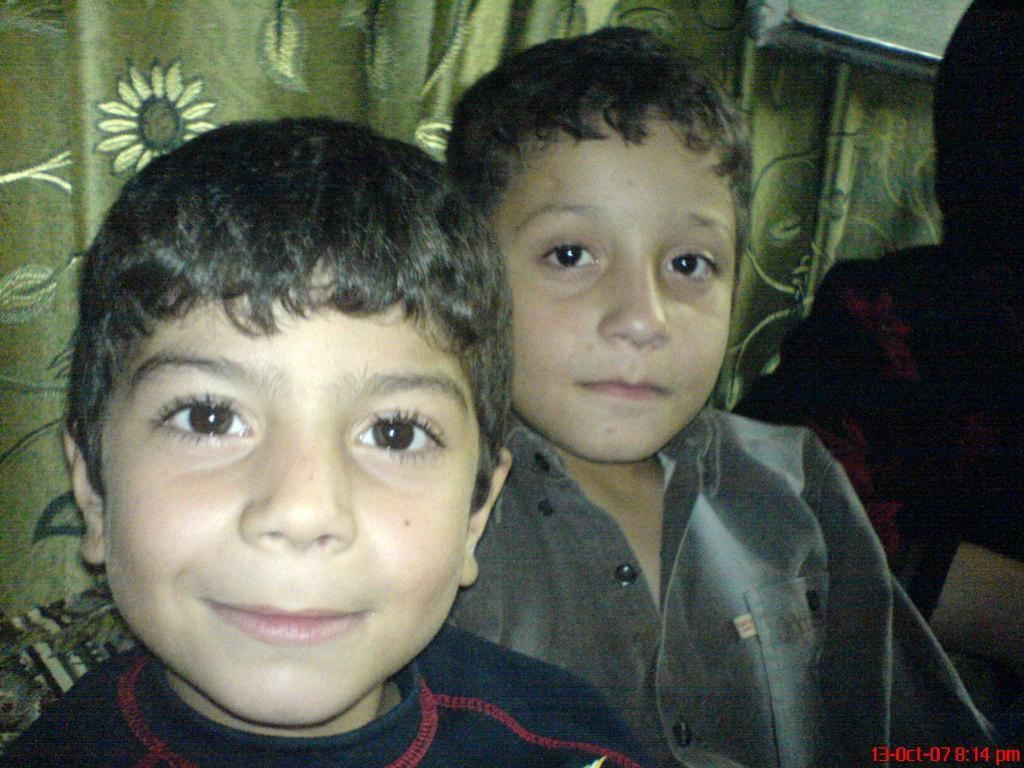Describe this image in one or two sentences. In the picture I can see two boys and looks like the boy on the left side is smiling. These are looking curtains in the background. 